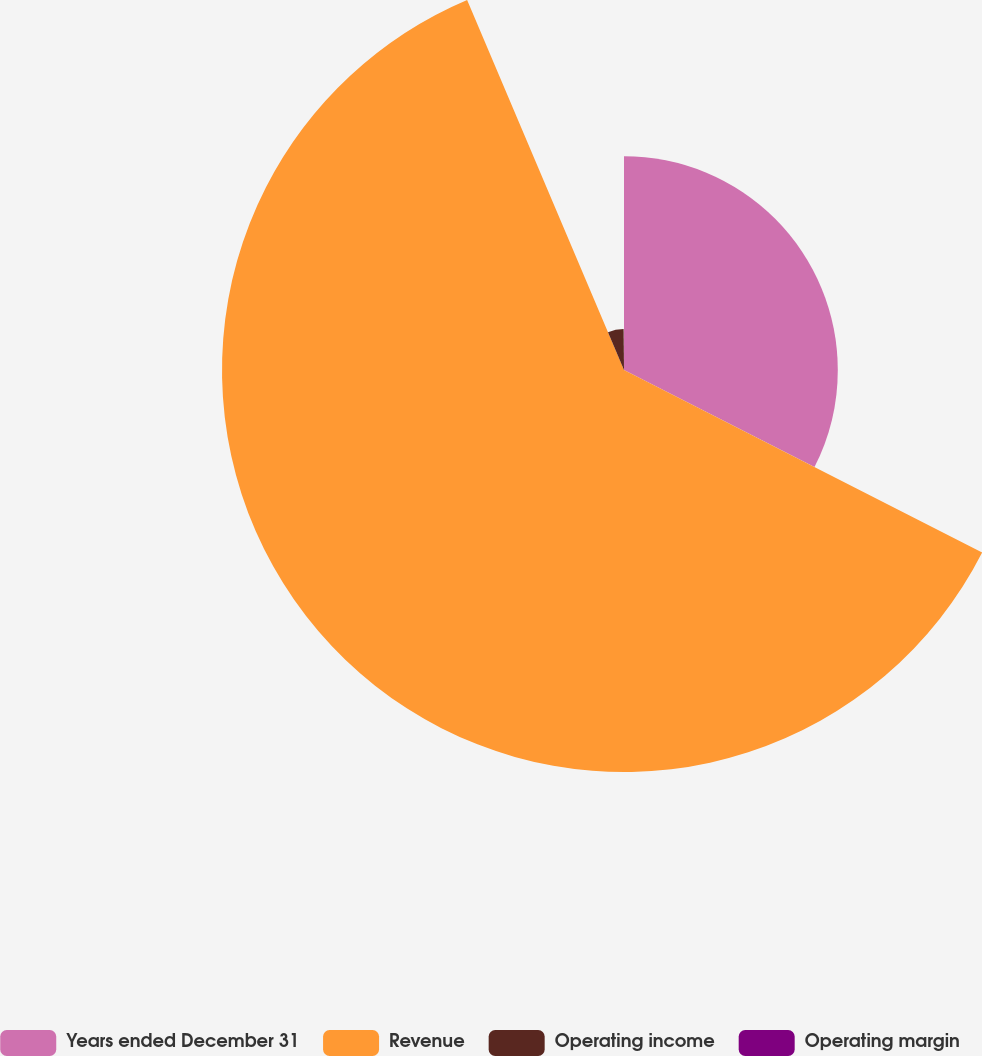<chart> <loc_0><loc_0><loc_500><loc_500><pie_chart><fcel>Years ended December 31<fcel>Revenue<fcel>Operating income<fcel>Operating margin<nl><fcel>32.5%<fcel>61.11%<fcel>6.24%<fcel>0.14%<nl></chart> 